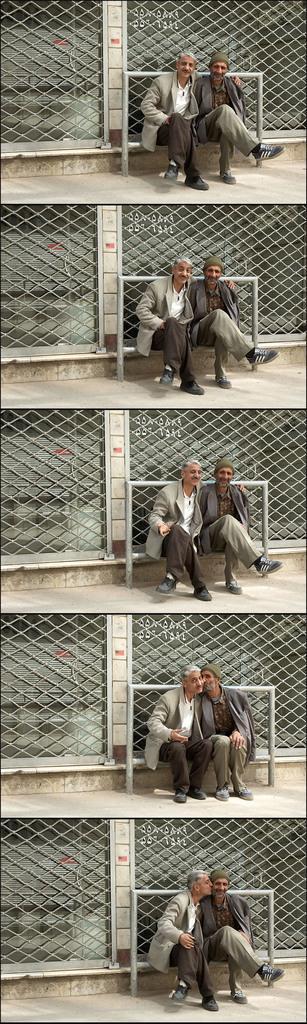In one or two sentences, can you explain what this image depicts? Collage pictures of the same people. These people are sitting. Background we can see mesh. In this picture this man is kissing to the beside person. In the other picture this person is kissing to the inside man. 